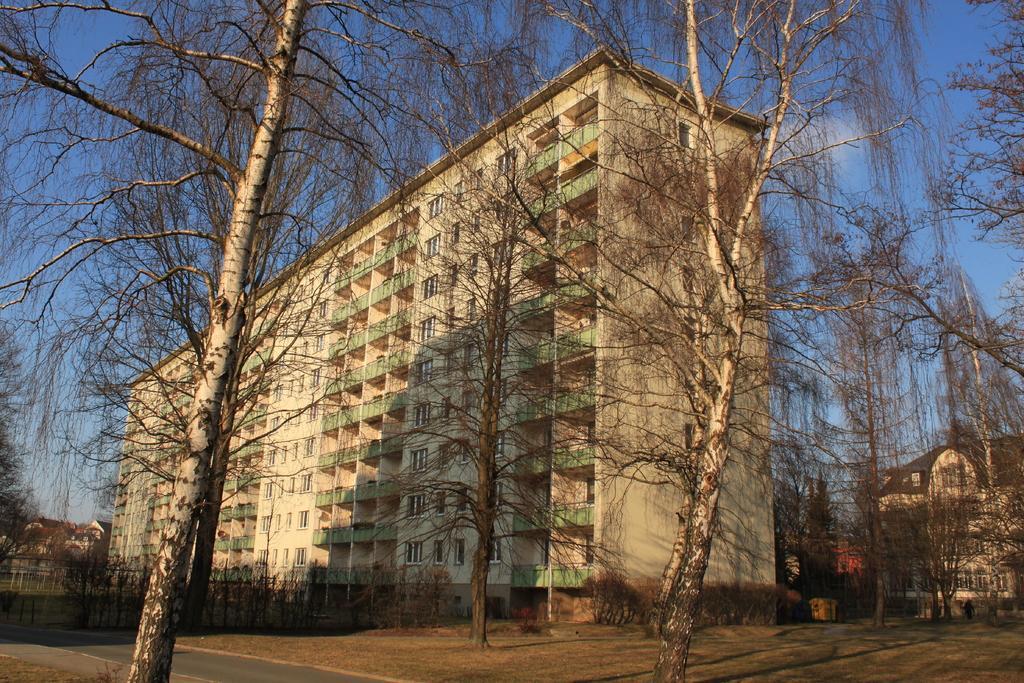Please provide a concise description of this image. In this image we can see dry trees. Behind the trees, we can see fence, plants and buildings. At the top of the image, we can see the sky. 